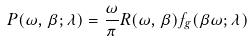<formula> <loc_0><loc_0><loc_500><loc_500>P ( \omega , \beta ; \lambda ) = \frac { \omega } { \pi } R ( \omega , \beta ) f _ { g } ( \beta \omega ; \lambda )</formula> 